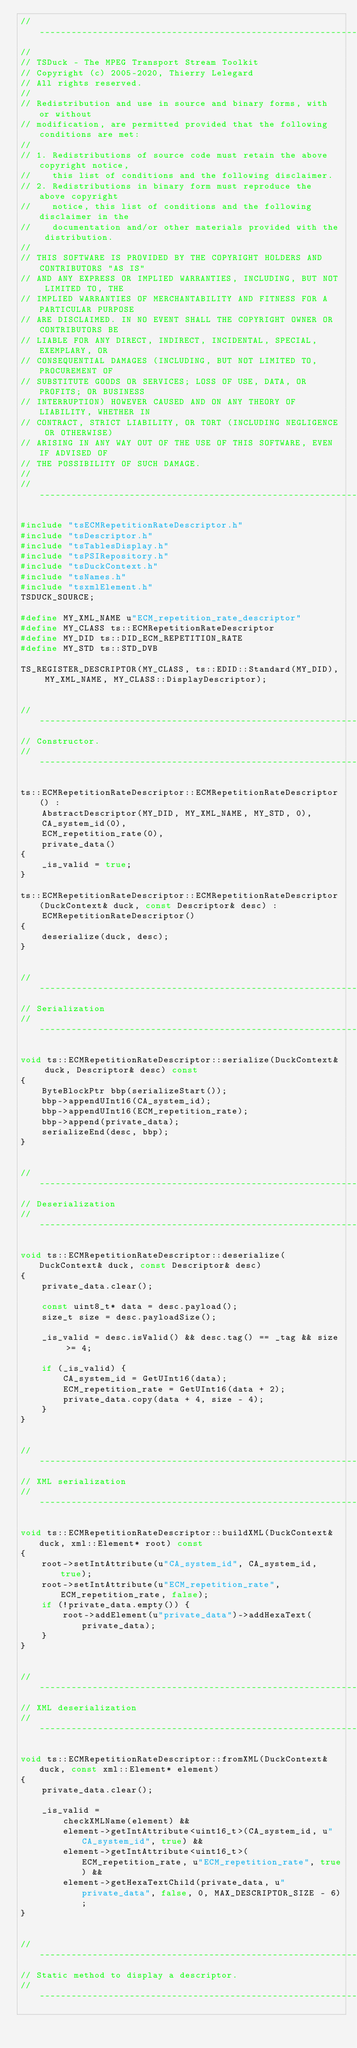<code> <loc_0><loc_0><loc_500><loc_500><_C++_>//----------------------------------------------------------------------------
//
// TSDuck - The MPEG Transport Stream Toolkit
// Copyright (c) 2005-2020, Thierry Lelegard
// All rights reserved.
//
// Redistribution and use in source and binary forms, with or without
// modification, are permitted provided that the following conditions are met:
//
// 1. Redistributions of source code must retain the above copyright notice,
//    this list of conditions and the following disclaimer.
// 2. Redistributions in binary form must reproduce the above copyright
//    notice, this list of conditions and the following disclaimer in the
//    documentation and/or other materials provided with the distribution.
//
// THIS SOFTWARE IS PROVIDED BY THE COPYRIGHT HOLDERS AND CONTRIBUTORS "AS IS"
// AND ANY EXPRESS OR IMPLIED WARRANTIES, INCLUDING, BUT NOT LIMITED TO, THE
// IMPLIED WARRANTIES OF MERCHANTABILITY AND FITNESS FOR A PARTICULAR PURPOSE
// ARE DISCLAIMED. IN NO EVENT SHALL THE COPYRIGHT OWNER OR CONTRIBUTORS BE
// LIABLE FOR ANY DIRECT, INDIRECT, INCIDENTAL, SPECIAL, EXEMPLARY, OR
// CONSEQUENTIAL DAMAGES (INCLUDING, BUT NOT LIMITED TO, PROCUREMENT OF
// SUBSTITUTE GOODS OR SERVICES; LOSS OF USE, DATA, OR PROFITS; OR BUSINESS
// INTERRUPTION) HOWEVER CAUSED AND ON ANY THEORY OF LIABILITY, WHETHER IN
// CONTRACT, STRICT LIABILITY, OR TORT (INCLUDING NEGLIGENCE OR OTHERWISE)
// ARISING IN ANY WAY OUT OF THE USE OF THIS SOFTWARE, EVEN IF ADVISED OF
// THE POSSIBILITY OF SUCH DAMAGE.
//
//----------------------------------------------------------------------------

#include "tsECMRepetitionRateDescriptor.h"
#include "tsDescriptor.h"
#include "tsTablesDisplay.h"
#include "tsPSIRepository.h"
#include "tsDuckContext.h"
#include "tsNames.h"
#include "tsxmlElement.h"
TSDUCK_SOURCE;

#define MY_XML_NAME u"ECM_repetition_rate_descriptor"
#define MY_CLASS ts::ECMRepetitionRateDescriptor
#define MY_DID ts::DID_ECM_REPETITION_RATE
#define MY_STD ts::STD_DVB

TS_REGISTER_DESCRIPTOR(MY_CLASS, ts::EDID::Standard(MY_DID), MY_XML_NAME, MY_CLASS::DisplayDescriptor);


//----------------------------------------------------------------------------
// Constructor.
//----------------------------------------------------------------------------

ts::ECMRepetitionRateDescriptor::ECMRepetitionRateDescriptor() :
    AbstractDescriptor(MY_DID, MY_XML_NAME, MY_STD, 0),
    CA_system_id(0),
    ECM_repetition_rate(0),
    private_data()
{
    _is_valid = true;
}

ts::ECMRepetitionRateDescriptor::ECMRepetitionRateDescriptor(DuckContext& duck, const Descriptor& desc) :
    ECMRepetitionRateDescriptor()
{
    deserialize(duck, desc);
}


//----------------------------------------------------------------------------
// Serialization
//----------------------------------------------------------------------------

void ts::ECMRepetitionRateDescriptor::serialize(DuckContext& duck, Descriptor& desc) const
{
    ByteBlockPtr bbp(serializeStart());
    bbp->appendUInt16(CA_system_id);
    bbp->appendUInt16(ECM_repetition_rate);
    bbp->append(private_data);
    serializeEnd(desc, bbp);
}


//----------------------------------------------------------------------------
// Deserialization
//----------------------------------------------------------------------------

void ts::ECMRepetitionRateDescriptor::deserialize(DuckContext& duck, const Descriptor& desc)
{
    private_data.clear();

    const uint8_t* data = desc.payload();
    size_t size = desc.payloadSize();

    _is_valid = desc.isValid() && desc.tag() == _tag && size >= 4;

    if (_is_valid) {
        CA_system_id = GetUInt16(data);
        ECM_repetition_rate = GetUInt16(data + 2);
        private_data.copy(data + 4, size - 4);
    }
}


//----------------------------------------------------------------------------
// XML serialization
//----------------------------------------------------------------------------

void ts::ECMRepetitionRateDescriptor::buildXML(DuckContext& duck, xml::Element* root) const
{
    root->setIntAttribute(u"CA_system_id", CA_system_id, true);
    root->setIntAttribute(u"ECM_repetition_rate", ECM_repetition_rate, false);
    if (!private_data.empty()) {
        root->addElement(u"private_data")->addHexaText(private_data);
    }
}


//----------------------------------------------------------------------------
// XML deserialization
//----------------------------------------------------------------------------

void ts::ECMRepetitionRateDescriptor::fromXML(DuckContext& duck, const xml::Element* element)
{
    private_data.clear();

    _is_valid =
        checkXMLName(element) &&
        element->getIntAttribute<uint16_t>(CA_system_id, u"CA_system_id", true) &&
        element->getIntAttribute<uint16_t>(ECM_repetition_rate, u"ECM_repetition_rate", true) &&
        element->getHexaTextChild(private_data, u"private_data", false, 0, MAX_DESCRIPTOR_SIZE - 6);
}


//----------------------------------------------------------------------------
// Static method to display a descriptor.
//----------------------------------------------------------------------------
</code> 